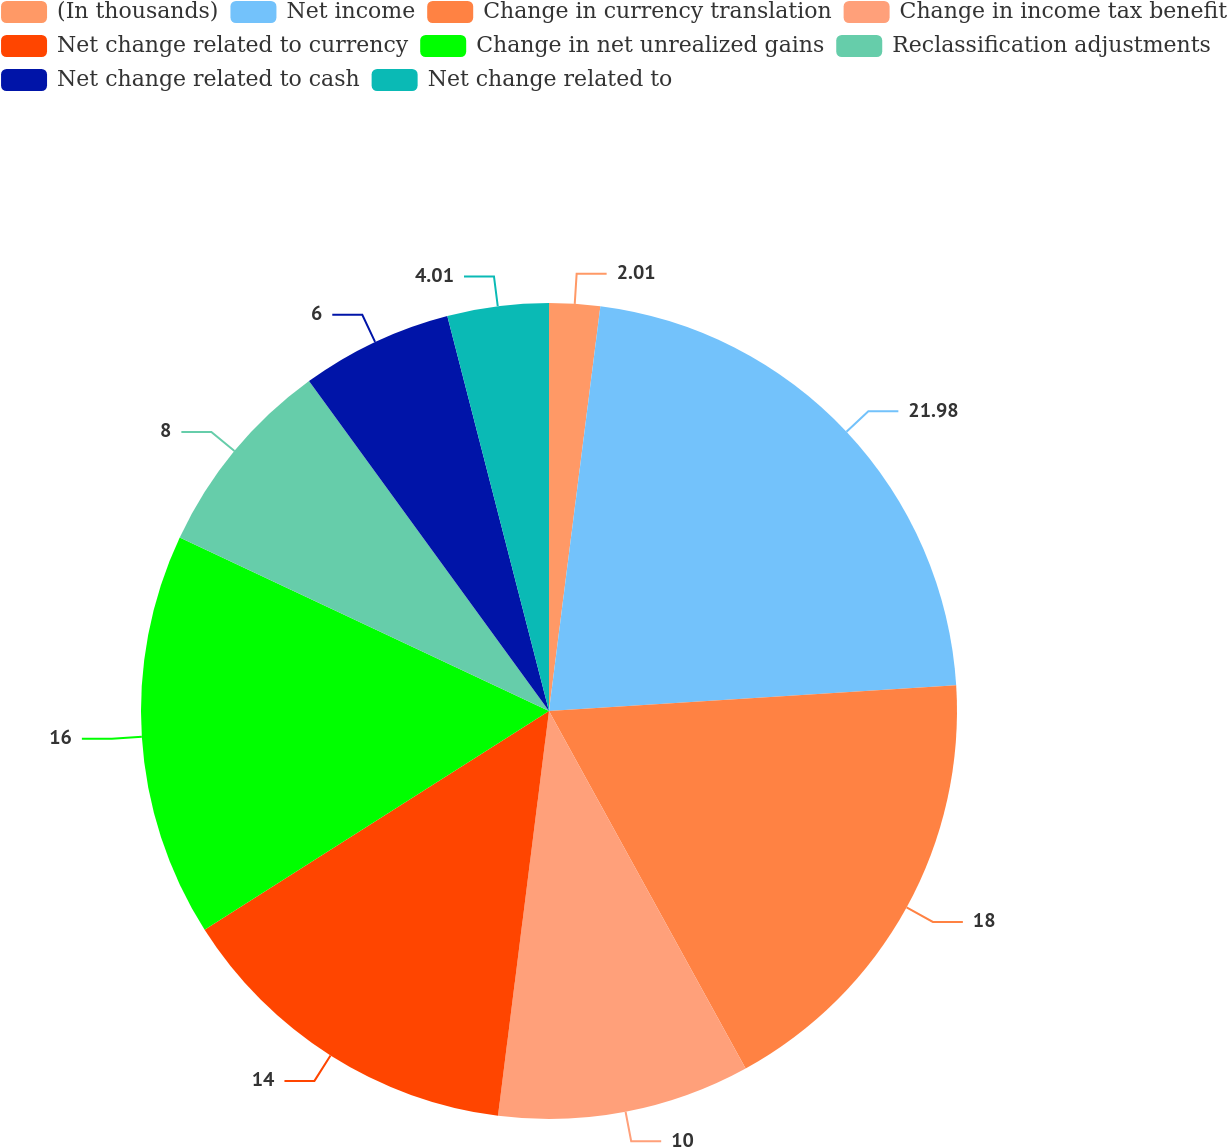<chart> <loc_0><loc_0><loc_500><loc_500><pie_chart><fcel>(In thousands)<fcel>Net income<fcel>Change in currency translation<fcel>Change in income tax benefit<fcel>Net change related to currency<fcel>Change in net unrealized gains<fcel>Reclassification adjustments<fcel>Net change related to cash<fcel>Net change related to<nl><fcel>2.01%<fcel>21.99%<fcel>18.0%<fcel>10.0%<fcel>14.0%<fcel>16.0%<fcel>8.0%<fcel>6.0%<fcel>4.01%<nl></chart> 